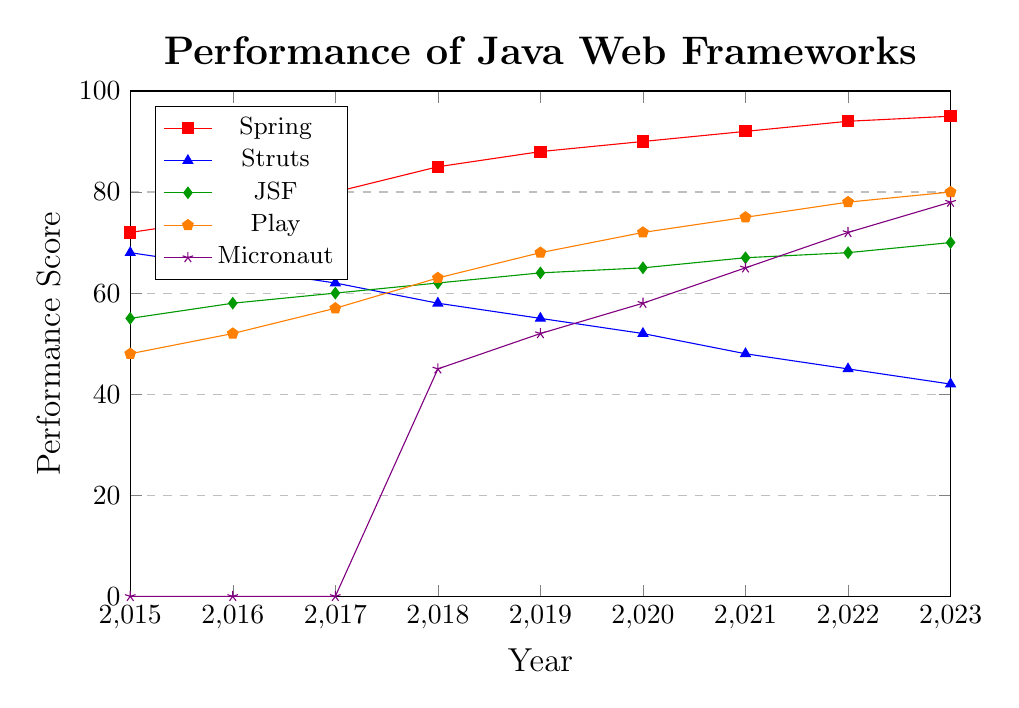What's the trend of Spring's performance from 2015 to 2023? The performance of Spring consistently increases over the years. It starts at 72 in 2015 and reaches 95 in 2023. This shows a continuous improvement in its performance across the timeline.
Answer: Consistently increasing Which framework shows the most significant decline in performance from 2015 to 2023? By observing the plot, Struts shows the most significant decline. It starts at 68 in 2015 and decreases to 42 in 2023.
Answer: Struts In which year did Micronaut first appear in the chart, and what was its initial performance score? Micronaut first appears in the year 2018. At this time, its performance score is 45. All previous years for Micronaut are marked as 0, indicating it was not present or measured then.
Answer: 2018, 45 How does the performance of JSF compare to that of Play in 2020? In 2020, the performance score of JSF is 65, whereas Play has a performance score of 72. This shows that Play performs better than JSF in 2020.
Answer: Play performs better Which framework has the highest performance score in 2023, and what is that score? By looking at the final data points in 2023, Spring has the highest performance score with a value of 95.
Answer: Spring, 95 What is the difference in performance between Play and Struts in 2021? In 2021, Play has a performance score of 75, while Struts has a score of 48. The difference in their performance scores can be calculated as 75 - 48 = 27.
Answer: 27 How did the performance score of Play change from 2015 to 2018? To find this, we check the scores for Play in 2015 and 2018. In 2015, its score is 48, and by 2018, it is 63. The change in performance score is 63 - 48 = 15.
Answer: Increased by 15 Compare the average performance score of Micronaut from 2018 to 2023 with that of JSF over the same period. First, calculate the average performance score for both frameworks from 2018 to 2023:
- Micronaut (2018: 45, 2019: 52, 2020: 58, 2021: 65, 2022: 72, 2023: 78) → (45 + 52 + 58 + 65 + 72 + 78) / 6 = 61.67
- JSF (2018: 62, 2019: 64, 2020: 65, 2021: 67, 2022: 68, 2023: 70) → (62 + 64 + 65 + 67 + 68 + 70) / 6 = 66
Thus, the average performance score of JSF is higher than that of Micronaut over this period.
Answer: JSF has a higher average What can be deduced about the trend of Struts' performance based on the given data? Struts shows a clear downward trend over the given years. It scores highest in 2015 with 68 and steadily decreases each year, reaching 42 by 2023. This suggests a decline in Struts' performance over time.
Answer: Declining trend 